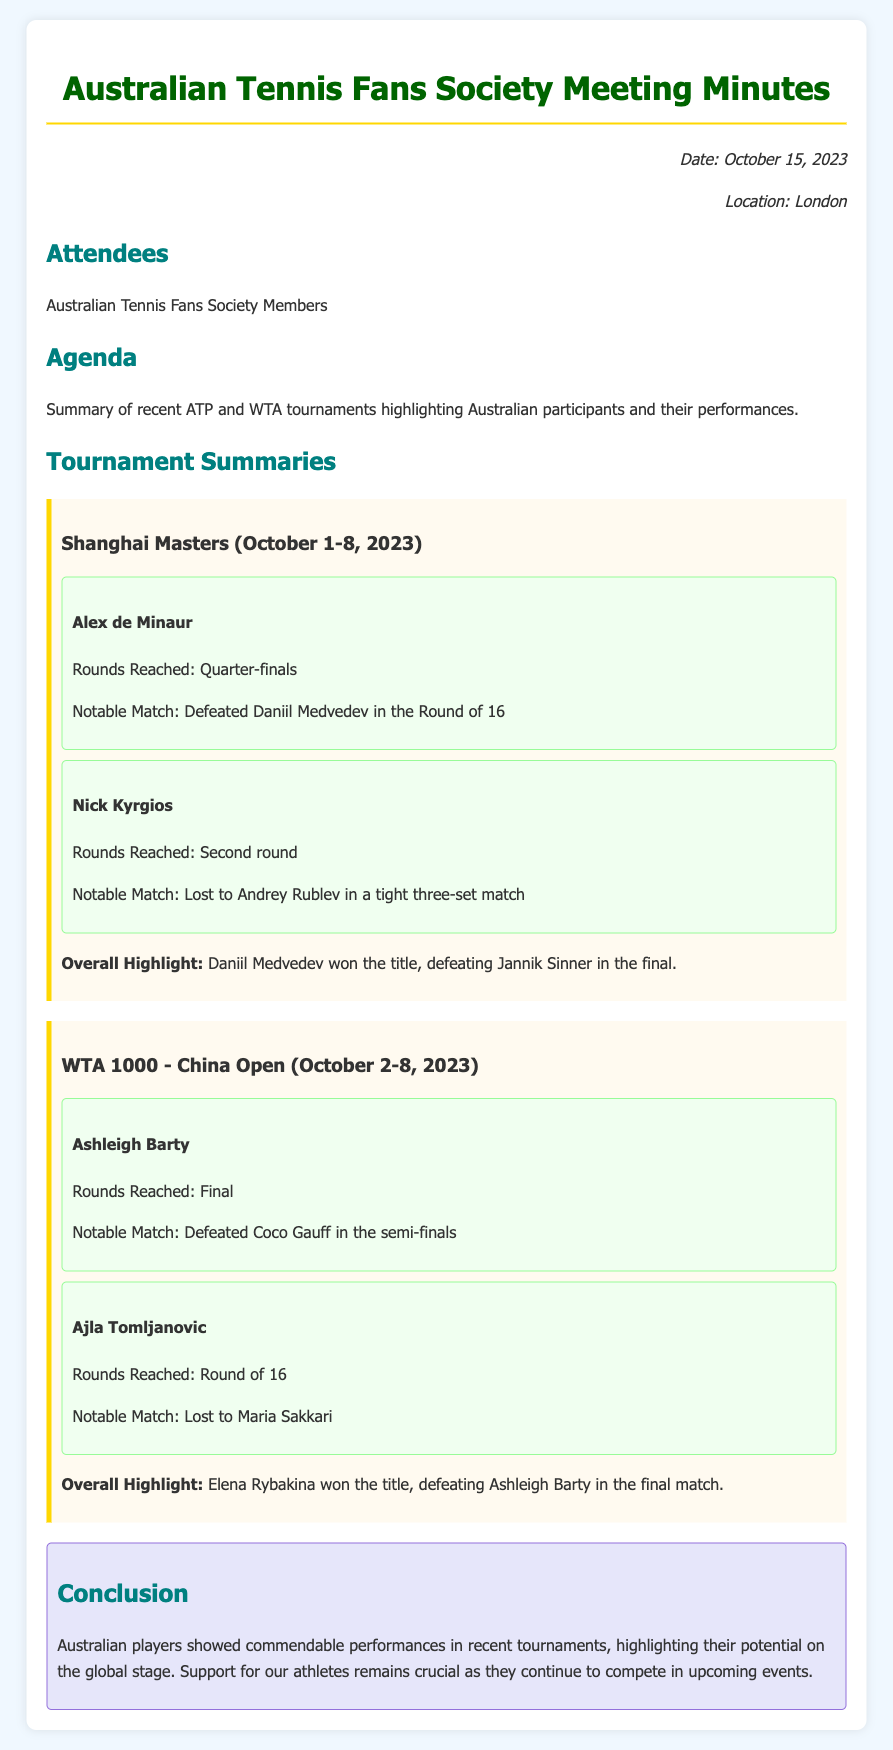What event did Alex de Minaur reach the quarter-finals in? The document states that Alex de Minaur reached the quarter-finals at the Shanghai Masters.
Answer: Shanghai Masters Who did Ashleigh Barty defeat in the semi-finals of the China Open? The document mentions that Ashleigh Barty defeated Coco Gauff in the semi-finals.
Answer: Coco Gauff What was Nick Kyrgios's notable match outcome at the Shanghai Masters? The document indicates that Nick Kyrgios lost to Andrey Rublev in a tight three-set match.
Answer: Lost to Andrey Rublev How many rounds did Ajla Tomljanovic reach in the China Open? The document states that Ajla Tomljanovic reached the Round of 16 in the China Open.
Answer: Round of 16 What is the overall highlight of the China Open? The document mentions that Elena Rybakina won the title, defeating Ashleigh Barty in the final match.
Answer: Elena Rybakina won the title What is the primary focus of the meeting minutes? The agenda of the meeting minutes highlights Australian participants and their performances in recent tournaments.
Answer: Australian participants and their performances How did Australian players perform in recent tournaments according to the conclusion? The conclusion summarizes that Australian players showed commendable performances in recent tournaments.
Answer: Commendable performances When were these meeting minutes documented? The date listed in the document for these meeting minutes is October 15, 2023.
Answer: October 15, 2023 